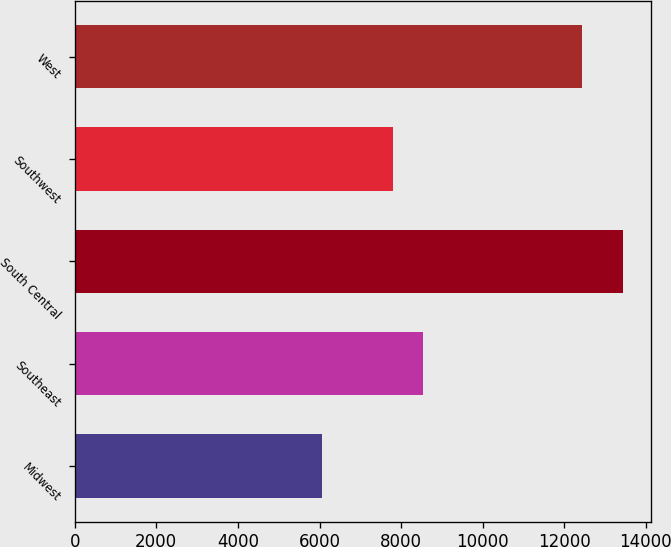Convert chart to OTSL. <chart><loc_0><loc_0><loc_500><loc_500><bar_chart><fcel>Midwest<fcel>Southeast<fcel>South Central<fcel>Southwest<fcel>West<nl><fcel>6050<fcel>8542.4<fcel>13444<fcel>7803<fcel>12445<nl></chart> 